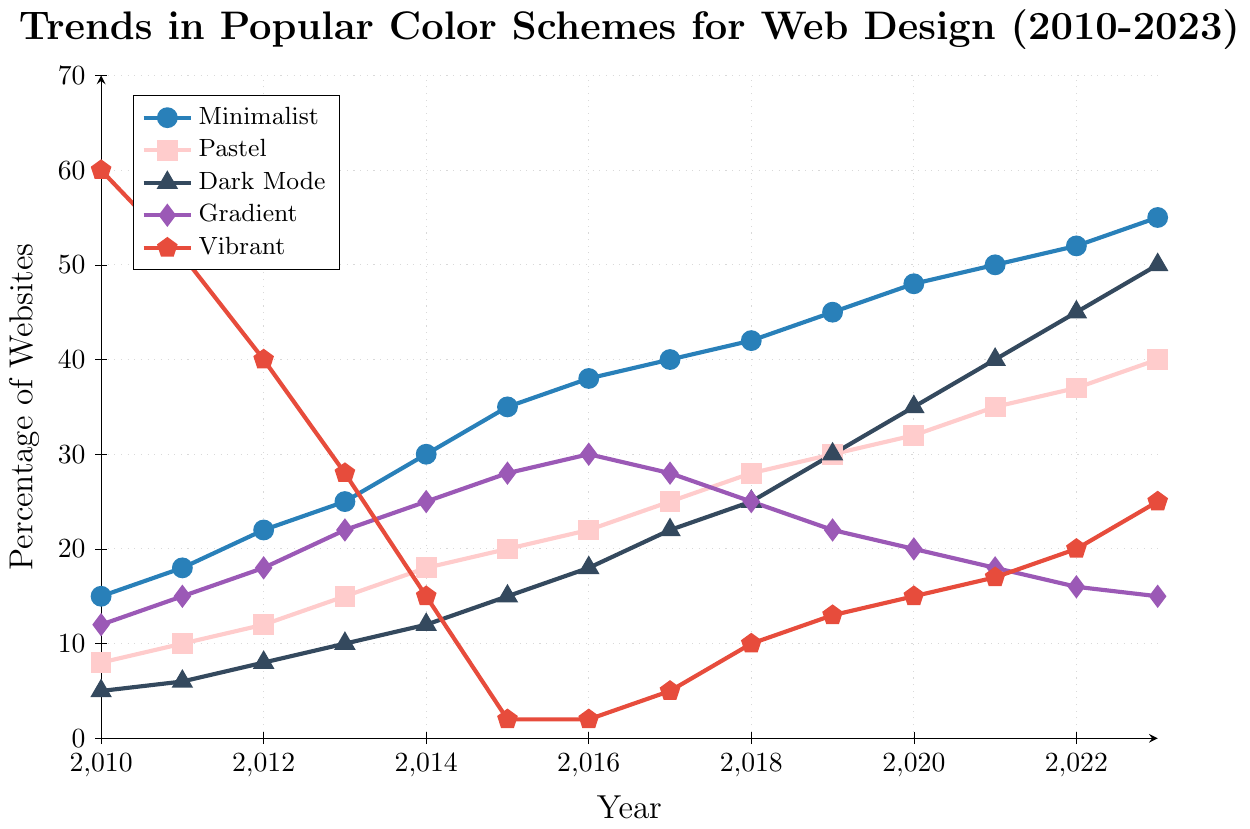What year did the usage of the Minimalist color scheme first surpass 40%? Check the data trend line for Minimalist; find the first year it crosses 40%, which is 2017.
Answer: 2017 Which color scheme had the highest percentage usage in 2010, and what was the percentage? Refer to the data for 2010 and find the color scheme with the highest value. Vibrant had the highest with 60%.
Answer: Vibrant, 60% By how much did the usage of the Pastel scheme increase from 2010 to 2023? Subtract the percentage of Pastel in 2010 from that in 2023. 40 - 8 = 32.
Answer: 32 In what year did Dark Mode overtake Gradient, and by how much did it surpass Gradient that year? Find the year where Dark Mode's percentage becomes higher than Gradient's. This happens in 2016 with Dark Mode at 18%, surpassing Gradient at 15%.
Answer: 2016, 3 What's the difference between the highest percentage usage of Minimalist and the lowest percentage usage of Vibrant throughout the entire period? Identify the highest and lowest values of Minimalist and Vibrant respectively from the data. Minimalist: 55%, Vibrant: 2%, so 55 - 2 = 53.
Answer: 53 Which color scheme showed a decreasing trend after initially increasing, and which year did the decrease start? Look for a trend where a scheme first goes up and then down. Gradient increased until 2016 (30%) and then started decreasing.
Answer: Gradient, 2017 What is the average percentage usage of the Dark Mode color scheme over the entire period? Sum the Dark Mode values and divide by the number of years (14). (5+6+8+10+12+15+18+22+25+30+35+40+45+50)/14 = 23.
Answer: 23 Compare the trend of the Minimalist and Vibrant color schemes in 2013. Which has a higher value and by how much? Compare the values in 2013 for Minimalist (25%) and Vibrant (28%). Vibrant is higher by 3%.
Answer: Vibrant, 3 Which color scheme had the highest percentage growth from its lowest point to its highest point? Calculate the percentage growth of each color scheme's highest point minus its lowest point. Minimalist: 55-15=40; Pastel: 40-8=32; Dark Mode: 50-5=45; Gradient: 30-15=15; Vibrant: 60-2=58. Vibrant had the highest growth.
Answer: Vibrant What year had the highest combined percentage for Minimalist and Pastel schemes? Add the values of Minimalist and Pastel for each year and find the maximum. 2023: 55 + 40 = 95.
Answer: 2023 